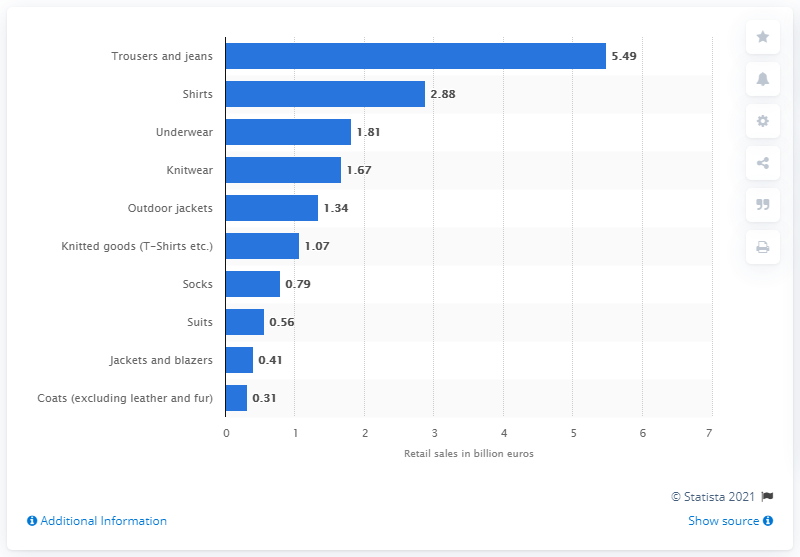Mention a couple of crucial points in this snapshot. In 2014, the sales of men's trousers and jeans in Germany generated 5.49 billion euros. 